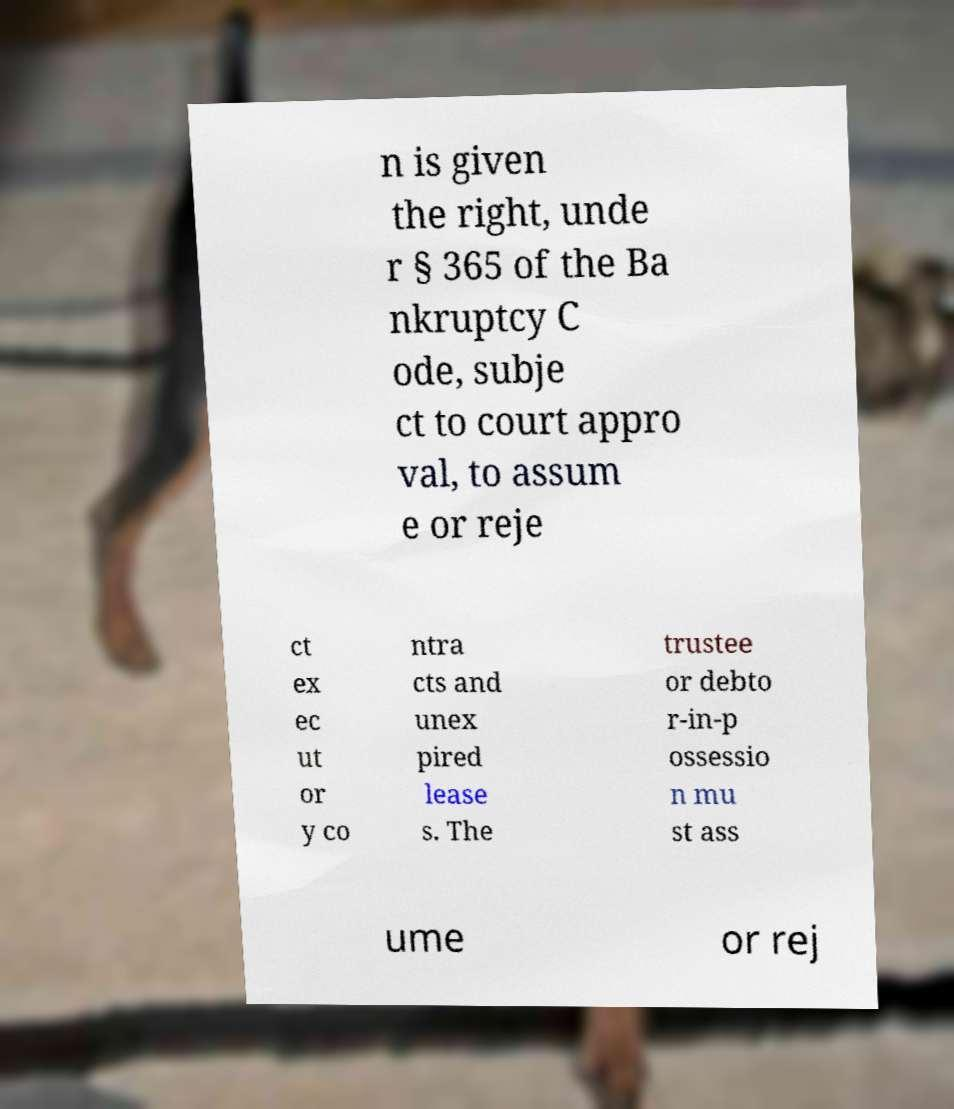Could you assist in decoding the text presented in this image and type it out clearly? n is given the right, unde r § 365 of the Ba nkruptcy C ode, subje ct to court appro val, to assum e or reje ct ex ec ut or y co ntra cts and unex pired lease s. The trustee or debto r-in-p ossessio n mu st ass ume or rej 